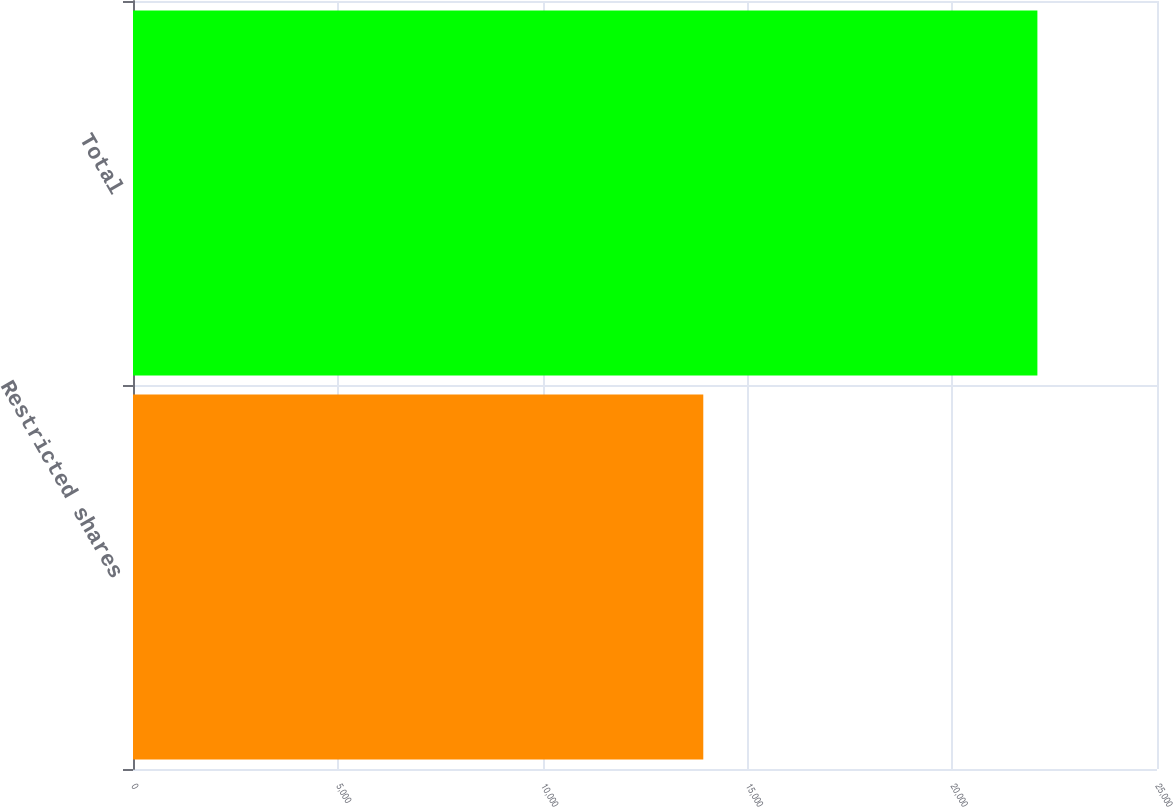Convert chart. <chart><loc_0><loc_0><loc_500><loc_500><bar_chart><fcel>Restricted shares<fcel>Total<nl><fcel>13923<fcel>22080<nl></chart> 